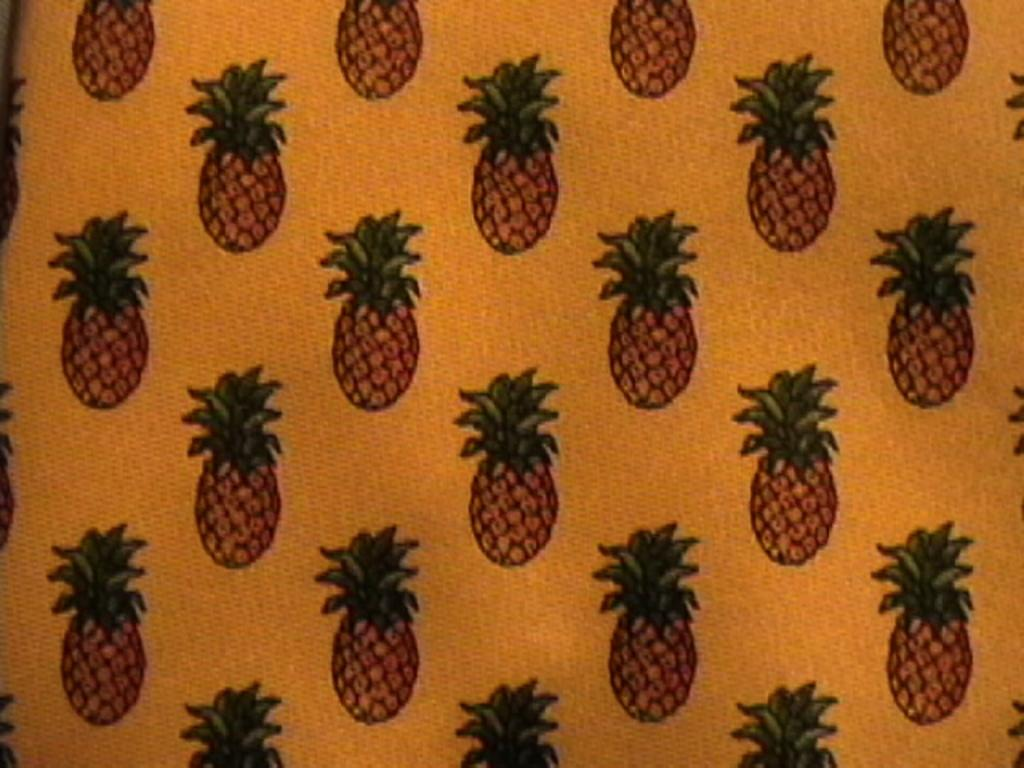What is present in the image with a specific design? There is a cloth in the image with a pineapple design on it. Can you describe the design on the cloth? The design on the cloth is a pineapple. What type of underwear is visible in the image? There is no underwear present in the image; it only features a cloth with a pineapple design. What kind of fruit is being used as an apparatus in the image? There is no fruit being used as an apparatus in the image; the cloth has a pineapple design, but it is not an actual fruit. 